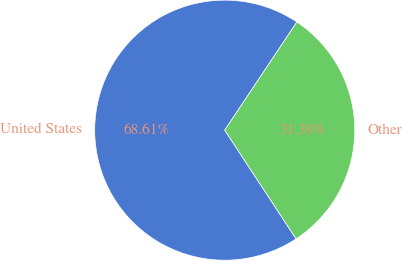Convert chart to OTSL. <chart><loc_0><loc_0><loc_500><loc_500><pie_chart><fcel>United States<fcel>Other<nl><fcel>68.61%<fcel>31.39%<nl></chart> 